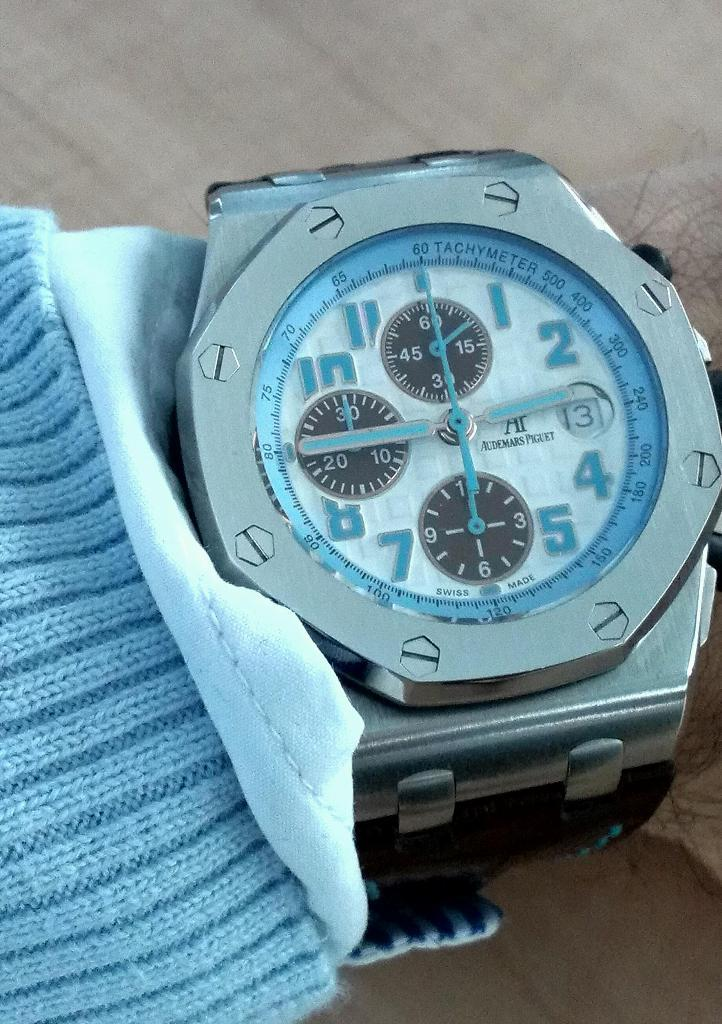<image>
Present a compact description of the photo's key features. A silver, white, and light blue watch with "Swiss Made" written across the bottom. 